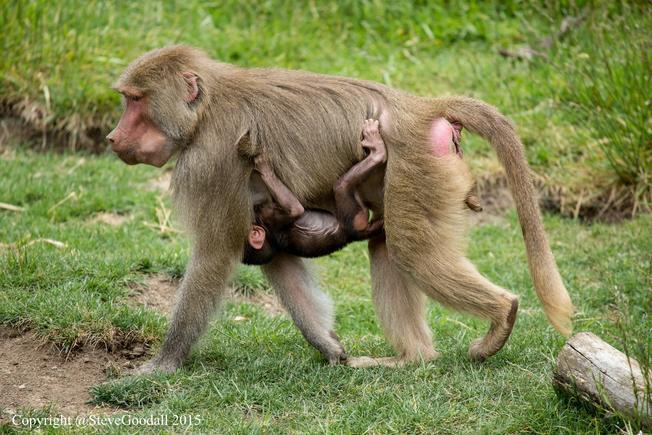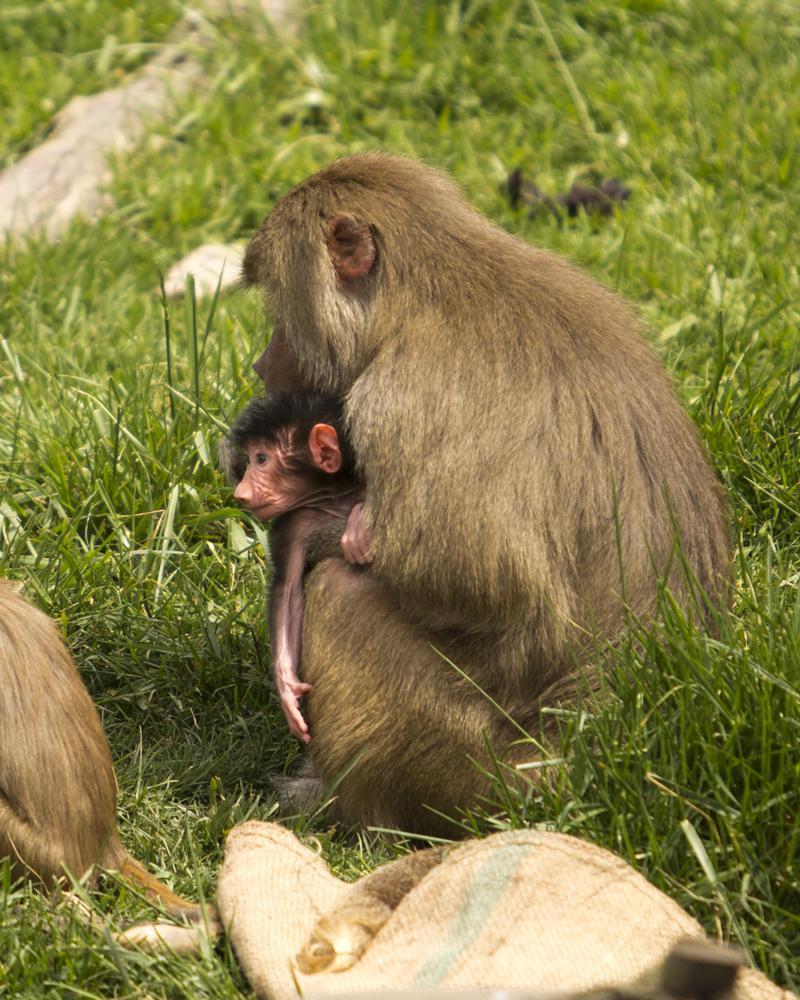The first image is the image on the left, the second image is the image on the right. Considering the images on both sides, is "One image shows a baby baboon riding on the body of a baboon in profile on all fours." valid? Answer yes or no. Yes. The first image is the image on the left, the second image is the image on the right. Analyze the images presented: Is the assertion "The left image contains no more than two primates." valid? Answer yes or no. Yes. 